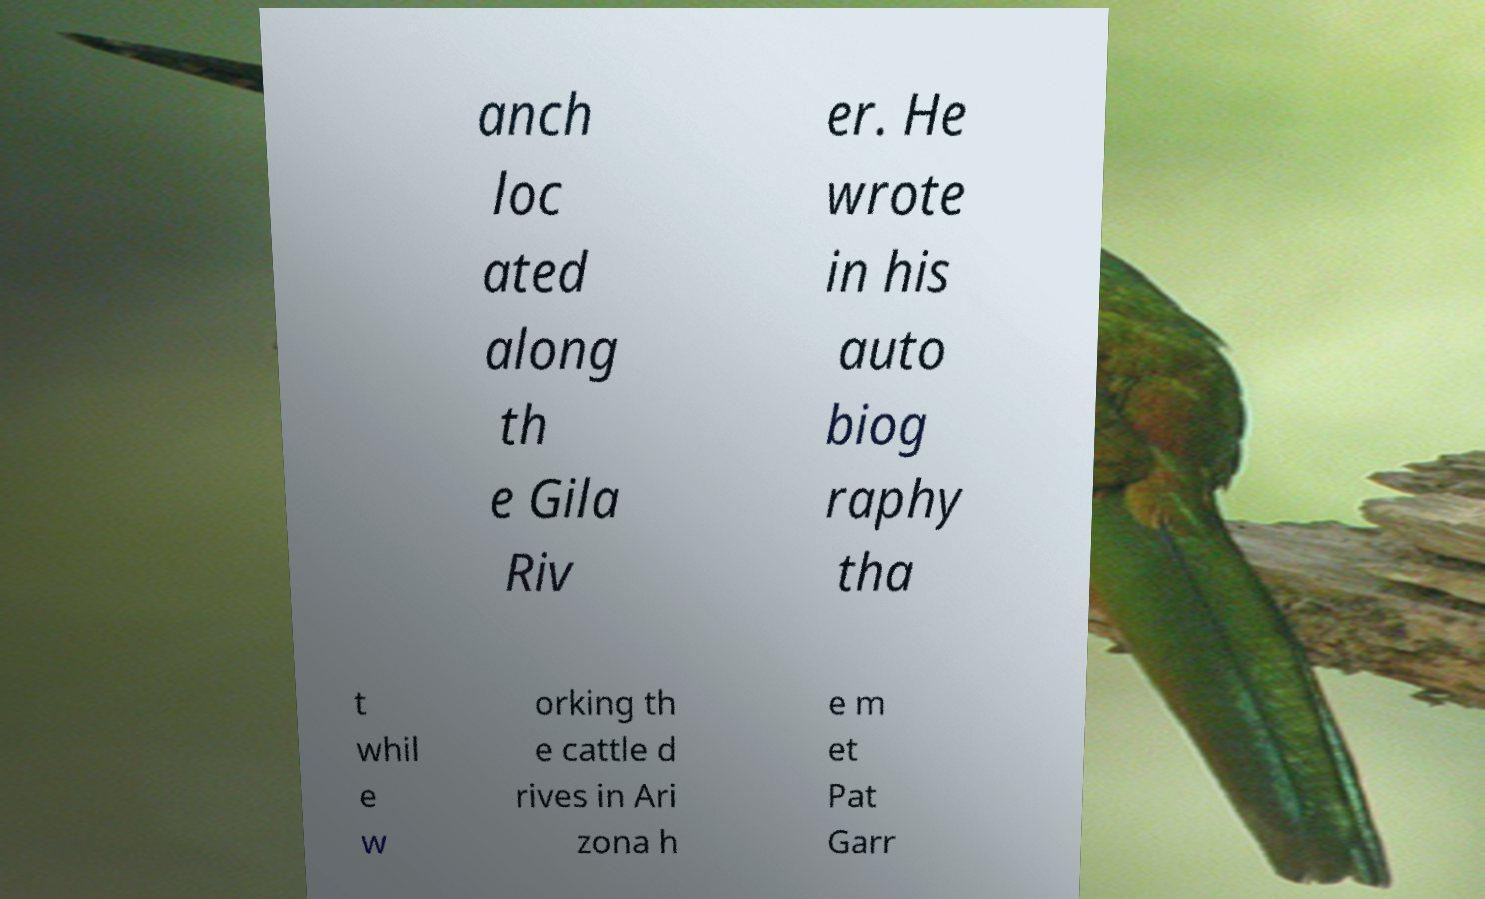Please read and relay the text visible in this image. What does it say? anch loc ated along th e Gila Riv er. He wrote in his auto biog raphy tha t whil e w orking th e cattle d rives in Ari zona h e m et Pat Garr 